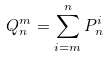Convert formula to latex. <formula><loc_0><loc_0><loc_500><loc_500>Q _ { n } ^ { m } = \sum _ { i = m } ^ { n } P _ { n } ^ { i }</formula> 